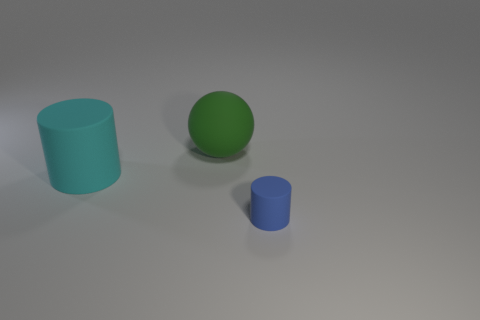Is there any information about the texture of the surfaces? The objects have a matte finish with no discernible texture, lending a smooth and uniform appearance under the lighting conditions present in the image. 